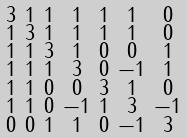<formula> <loc_0><loc_0><loc_500><loc_500>\begin{smallmatrix} 3 & 1 & 1 & 1 & 1 & 1 & 0 \\ 1 & 3 & 1 & 1 & 1 & 1 & 0 \\ 1 & 1 & 3 & 1 & 0 & 0 & 1 \\ 1 & 1 & 1 & 3 & 0 & - 1 & 1 \\ 1 & 1 & 0 & 0 & 3 & 1 & 0 \\ 1 & 1 & 0 & - 1 & 1 & 3 & - 1 \\ 0 & 0 & 1 & 1 & 0 & - 1 & 3 \end{smallmatrix}</formula> 